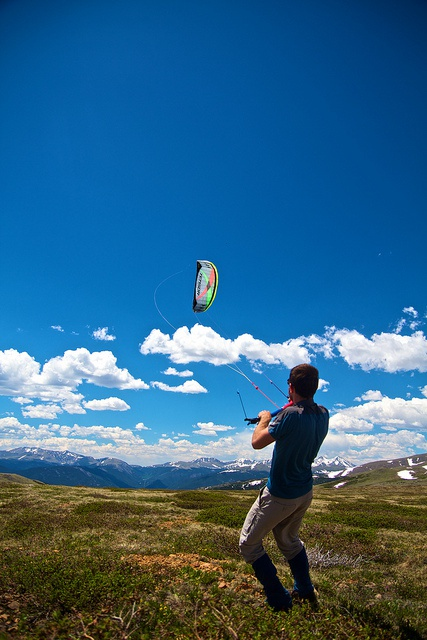Describe the objects in this image and their specific colors. I can see people in navy, black, maroon, and gray tones and kite in navy, black, darkgray, and gray tones in this image. 